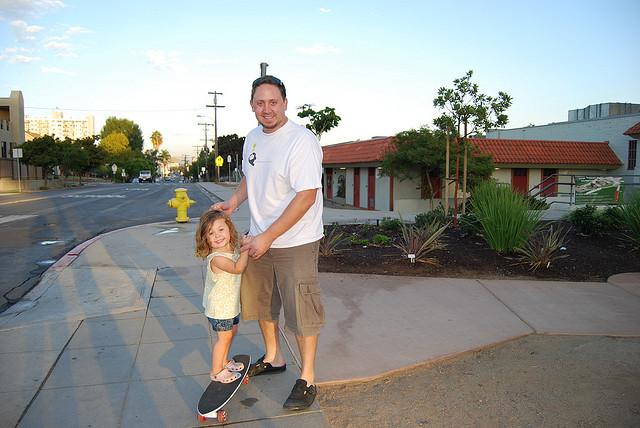What are the reddish and green plants called in the forefront of the planter? ferns 